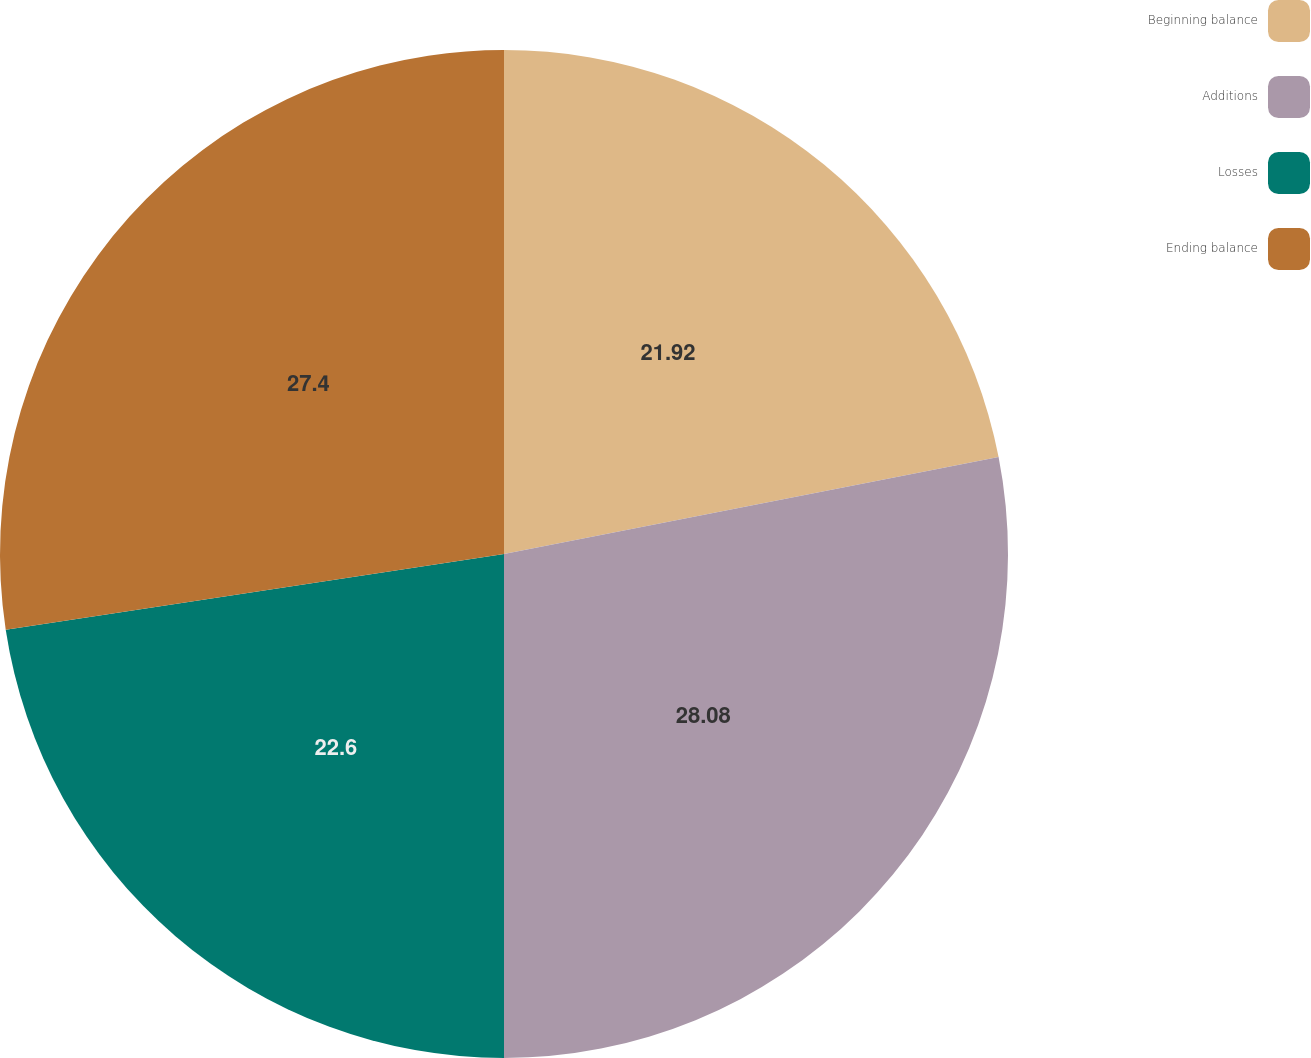Convert chart. <chart><loc_0><loc_0><loc_500><loc_500><pie_chart><fcel>Beginning balance<fcel>Additions<fcel>Losses<fcel>Ending balance<nl><fcel>21.92%<fcel>28.08%<fcel>22.6%<fcel>27.4%<nl></chart> 